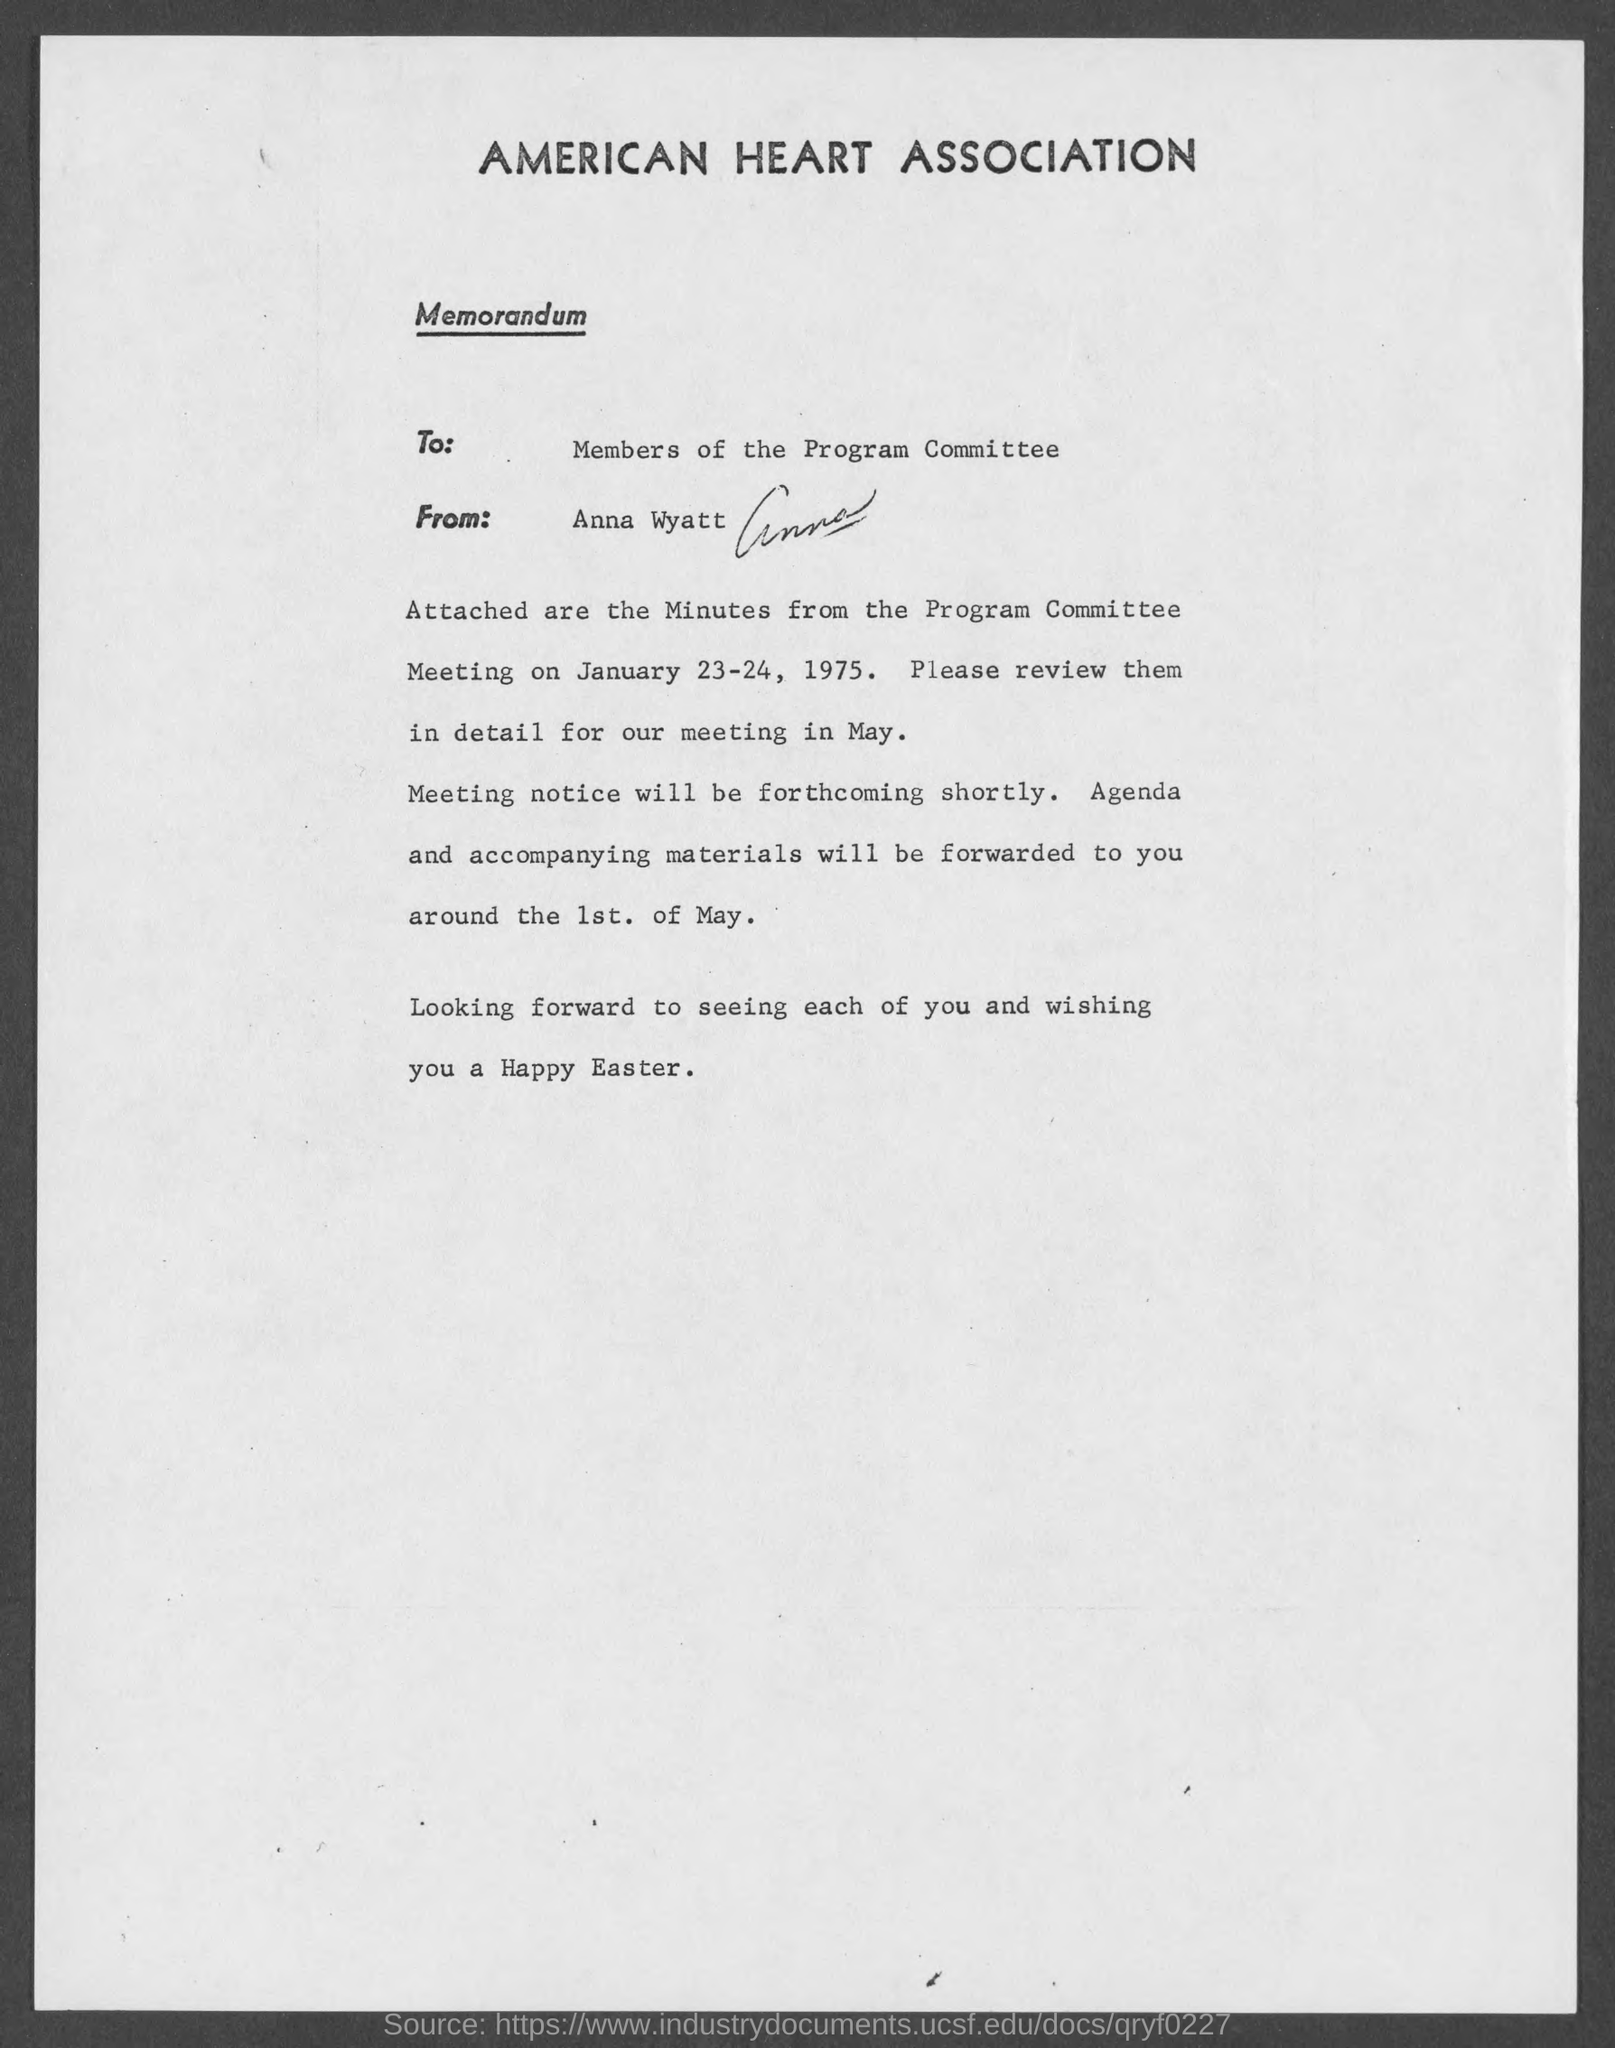Who is the sender of the memorandum?
Keep it short and to the point. Anna Wyatt. To whom, the memorandum is addressed?
Offer a terse response. Members of the Program Committee. 